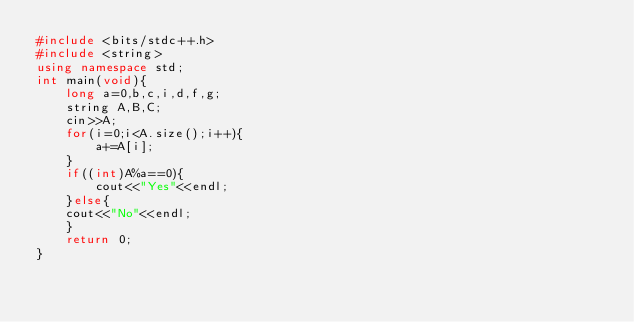<code> <loc_0><loc_0><loc_500><loc_500><_C++_>#include <bits/stdc++.h>
#include <string>
using namespace std;
int main(void){
	long a=0,b,c,i,d,f,g;
	string A,B,C;
	cin>>A;
	for(i=0;i<A.size();i++){
		a+=A[i];
	}
	if((int)A%a==0){
		cout<<"Yes"<<endl;
	}else{
	cout<<"No"<<endl;
	}
	return 0;
}</code> 